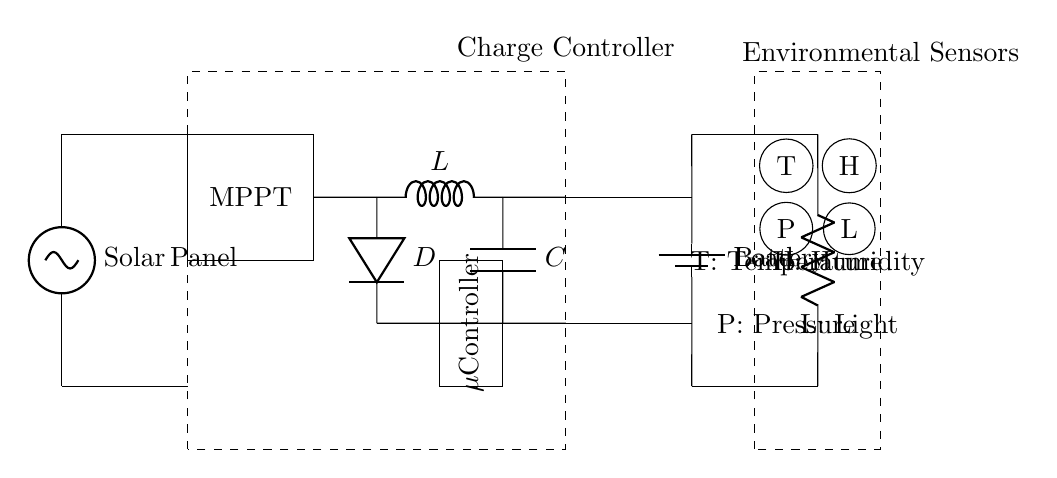What is the main power source for this circuit? The main power source is the solar panel, which provides voltage to the entire circuit.
Answer: Solar Panel What component regulates the voltage from the solar panel? The charge controller is responsible for regulating the voltage and current from the solar panel to prevent overcharging the battery.
Answer: Charge Controller What does the MPPT stand for? The acronym MPPT stands for Maximum Power Point Tracking, which optimizes the power output from the solar panel.
Answer: Maximum Power Point Tracking Which components are used to store energy in this circuit? The battery is the component used to store energy produced by the solar panel for later use.
Answer: Battery How many environmental sensors are shown in the circuit? There are four environmental sensors depicted in the circuit, which monitor different environmental parameters.
Answer: Four What is the function of the buck converter in this circuit? The buck converter reduces the voltage from the charge controller to the appropriate level needed by the load.
Answer: Reduces voltage What type of load is this circuit designed to support? The circuit supports a resistive load, as indicated by the resistor symbol in the diagram.
Answer: Resistive load 